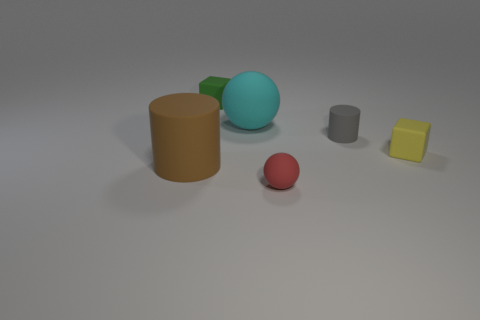The big ball that is made of the same material as the small green block is what color?
Ensure brevity in your answer.  Cyan. What number of objects are either big green metallic cylinders or big cyan matte spheres?
Your answer should be compact. 1. There is a red matte object that is the same size as the gray matte object; what shape is it?
Your response must be concise. Sphere. What number of rubber objects are on the right side of the brown cylinder and behind the red rubber sphere?
Provide a short and direct response. 4. What is the material of the tiny yellow block that is on the right side of the tiny green cube?
Your answer should be very brief. Rubber. There is a gray cylinder that is made of the same material as the green object; what is its size?
Your response must be concise. Small. There is a matte cylinder that is left of the tiny gray matte cylinder; is it the same size as the matte cylinder behind the large brown thing?
Offer a very short reply. No. What is the material of the green block that is the same size as the yellow matte block?
Offer a terse response. Rubber. There is a object that is both to the left of the cyan sphere and behind the large brown rubber cylinder; what is its material?
Your answer should be very brief. Rubber. Are any green shiny balls visible?
Ensure brevity in your answer.  No. 